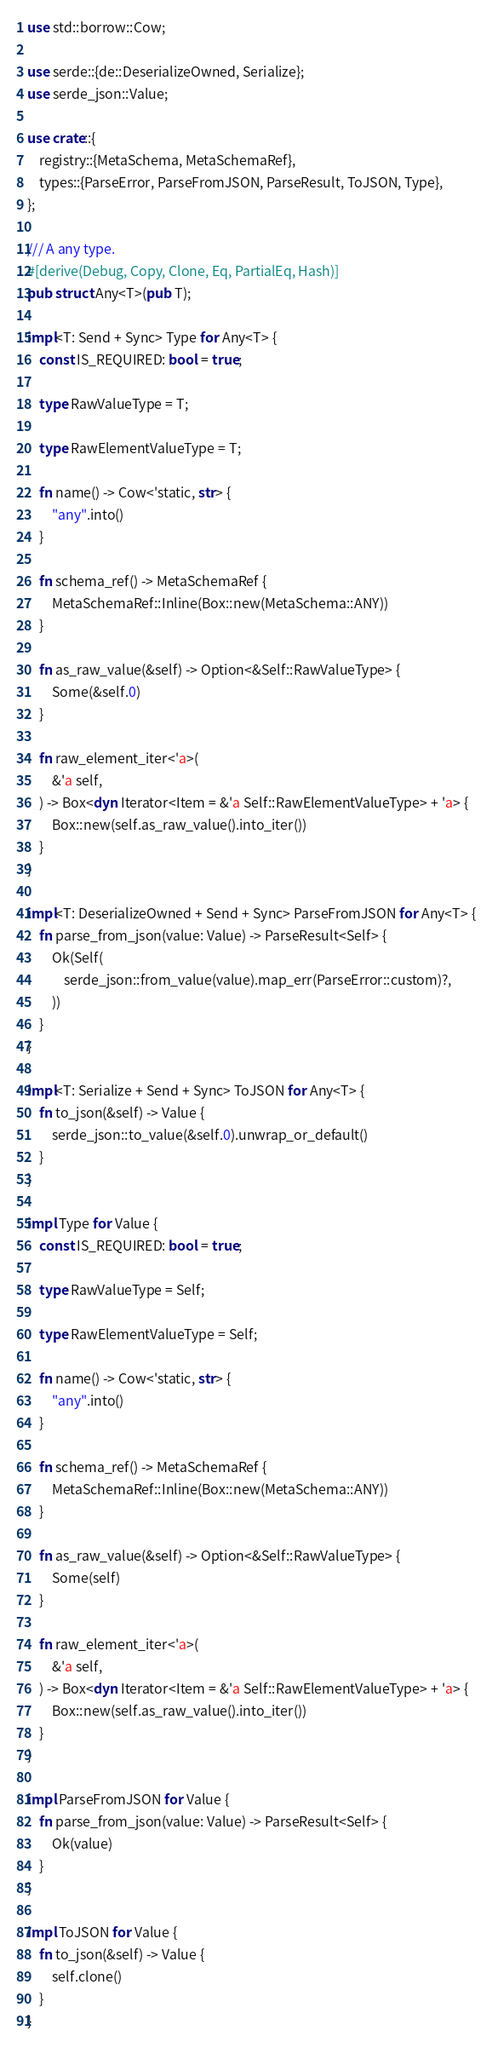<code> <loc_0><loc_0><loc_500><loc_500><_Rust_>use std::borrow::Cow;

use serde::{de::DeserializeOwned, Serialize};
use serde_json::Value;

use crate::{
    registry::{MetaSchema, MetaSchemaRef},
    types::{ParseError, ParseFromJSON, ParseResult, ToJSON, Type},
};

/// A any type.
#[derive(Debug, Copy, Clone, Eq, PartialEq, Hash)]
pub struct Any<T>(pub T);

impl<T: Send + Sync> Type for Any<T> {
    const IS_REQUIRED: bool = true;

    type RawValueType = T;

    type RawElementValueType = T;

    fn name() -> Cow<'static, str> {
        "any".into()
    }

    fn schema_ref() -> MetaSchemaRef {
        MetaSchemaRef::Inline(Box::new(MetaSchema::ANY))
    }

    fn as_raw_value(&self) -> Option<&Self::RawValueType> {
        Some(&self.0)
    }

    fn raw_element_iter<'a>(
        &'a self,
    ) -> Box<dyn Iterator<Item = &'a Self::RawElementValueType> + 'a> {
        Box::new(self.as_raw_value().into_iter())
    }
}

impl<T: DeserializeOwned + Send + Sync> ParseFromJSON for Any<T> {
    fn parse_from_json(value: Value) -> ParseResult<Self> {
        Ok(Self(
            serde_json::from_value(value).map_err(ParseError::custom)?,
        ))
    }
}

impl<T: Serialize + Send + Sync> ToJSON for Any<T> {
    fn to_json(&self) -> Value {
        serde_json::to_value(&self.0).unwrap_or_default()
    }
}

impl Type for Value {
    const IS_REQUIRED: bool = true;

    type RawValueType = Self;

    type RawElementValueType = Self;

    fn name() -> Cow<'static, str> {
        "any".into()
    }

    fn schema_ref() -> MetaSchemaRef {
        MetaSchemaRef::Inline(Box::new(MetaSchema::ANY))
    }

    fn as_raw_value(&self) -> Option<&Self::RawValueType> {
        Some(self)
    }

    fn raw_element_iter<'a>(
        &'a self,
    ) -> Box<dyn Iterator<Item = &'a Self::RawElementValueType> + 'a> {
        Box::new(self.as_raw_value().into_iter())
    }
}

impl ParseFromJSON for Value {
    fn parse_from_json(value: Value) -> ParseResult<Self> {
        Ok(value)
    }
}

impl ToJSON for Value {
    fn to_json(&self) -> Value {
        self.clone()
    }
}
</code> 